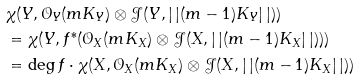<formula> <loc_0><loc_0><loc_500><loc_500>& \chi ( Y , \mathcal { O } _ { Y } ( m K _ { Y } ) \otimes \mathcal { J } ( Y , | \, | ( m - 1 ) K _ { Y } | \, | ) ) \\ & = \chi ( Y , f ^ { * } ( \mathcal { O } _ { X } ( m K _ { X } ) \otimes \mathcal { J } ( X , | \, | ( m - 1 ) K _ { X } | \, | ) ) ) \\ & = \deg f \cdot \chi ( X , \mathcal { O } _ { X } ( m K _ { X } ) \otimes \mathcal { J } ( X , | \, | ( m - 1 ) K _ { X } | \, | ) )</formula> 